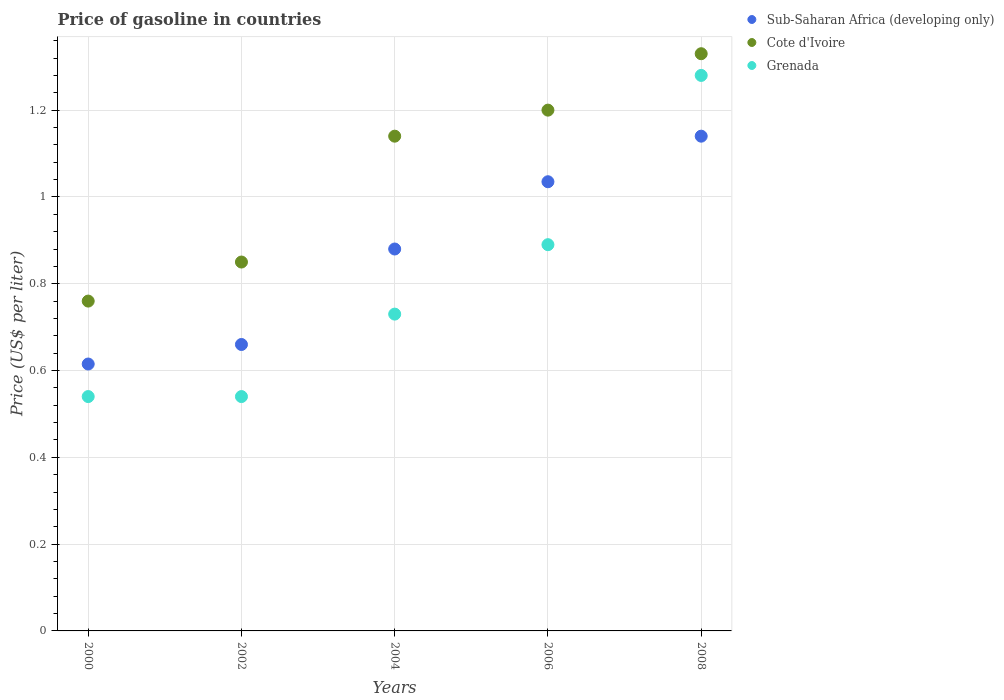Is the number of dotlines equal to the number of legend labels?
Offer a terse response. Yes. What is the price of gasoline in Grenada in 2006?
Make the answer very short. 0.89. Across all years, what is the maximum price of gasoline in Sub-Saharan Africa (developing only)?
Ensure brevity in your answer.  1.14. Across all years, what is the minimum price of gasoline in Sub-Saharan Africa (developing only)?
Ensure brevity in your answer.  0.61. In which year was the price of gasoline in Sub-Saharan Africa (developing only) maximum?
Your response must be concise. 2008. In which year was the price of gasoline in Cote d'Ivoire minimum?
Provide a succinct answer. 2000. What is the total price of gasoline in Cote d'Ivoire in the graph?
Provide a short and direct response. 5.28. What is the difference between the price of gasoline in Grenada in 2004 and that in 2008?
Offer a terse response. -0.55. What is the difference between the price of gasoline in Grenada in 2006 and the price of gasoline in Cote d'Ivoire in 2008?
Make the answer very short. -0.44. What is the average price of gasoline in Sub-Saharan Africa (developing only) per year?
Your answer should be compact. 0.87. In the year 2006, what is the difference between the price of gasoline in Cote d'Ivoire and price of gasoline in Sub-Saharan Africa (developing only)?
Offer a very short reply. 0.17. What is the ratio of the price of gasoline in Grenada in 2004 to that in 2008?
Your response must be concise. 0.57. What is the difference between the highest and the second highest price of gasoline in Sub-Saharan Africa (developing only)?
Provide a succinct answer. 0.1. What is the difference between the highest and the lowest price of gasoline in Cote d'Ivoire?
Your answer should be compact. 0.57. Is the sum of the price of gasoline in Cote d'Ivoire in 2002 and 2006 greater than the maximum price of gasoline in Sub-Saharan Africa (developing only) across all years?
Ensure brevity in your answer.  Yes. Is it the case that in every year, the sum of the price of gasoline in Cote d'Ivoire and price of gasoline in Sub-Saharan Africa (developing only)  is greater than the price of gasoline in Grenada?
Your answer should be compact. Yes. Is the price of gasoline in Sub-Saharan Africa (developing only) strictly greater than the price of gasoline in Grenada over the years?
Offer a terse response. No. Are the values on the major ticks of Y-axis written in scientific E-notation?
Your answer should be very brief. No. Does the graph contain any zero values?
Offer a very short reply. No. Where does the legend appear in the graph?
Provide a succinct answer. Top right. How many legend labels are there?
Make the answer very short. 3. How are the legend labels stacked?
Ensure brevity in your answer.  Vertical. What is the title of the graph?
Offer a terse response. Price of gasoline in countries. Does "Estonia" appear as one of the legend labels in the graph?
Offer a terse response. No. What is the label or title of the Y-axis?
Give a very brief answer. Price (US$ per liter). What is the Price (US$ per liter) of Sub-Saharan Africa (developing only) in 2000?
Offer a terse response. 0.61. What is the Price (US$ per liter) in Cote d'Ivoire in 2000?
Give a very brief answer. 0.76. What is the Price (US$ per liter) in Grenada in 2000?
Your answer should be compact. 0.54. What is the Price (US$ per liter) of Sub-Saharan Africa (developing only) in 2002?
Your response must be concise. 0.66. What is the Price (US$ per liter) of Grenada in 2002?
Your answer should be compact. 0.54. What is the Price (US$ per liter) of Sub-Saharan Africa (developing only) in 2004?
Give a very brief answer. 0.88. What is the Price (US$ per liter) in Cote d'Ivoire in 2004?
Offer a terse response. 1.14. What is the Price (US$ per liter) in Grenada in 2004?
Make the answer very short. 0.73. What is the Price (US$ per liter) in Sub-Saharan Africa (developing only) in 2006?
Offer a terse response. 1.03. What is the Price (US$ per liter) of Grenada in 2006?
Provide a succinct answer. 0.89. What is the Price (US$ per liter) in Sub-Saharan Africa (developing only) in 2008?
Ensure brevity in your answer.  1.14. What is the Price (US$ per liter) in Cote d'Ivoire in 2008?
Offer a terse response. 1.33. What is the Price (US$ per liter) in Grenada in 2008?
Ensure brevity in your answer.  1.28. Across all years, what is the maximum Price (US$ per liter) in Sub-Saharan Africa (developing only)?
Make the answer very short. 1.14. Across all years, what is the maximum Price (US$ per liter) in Cote d'Ivoire?
Your response must be concise. 1.33. Across all years, what is the maximum Price (US$ per liter) in Grenada?
Provide a succinct answer. 1.28. Across all years, what is the minimum Price (US$ per liter) of Sub-Saharan Africa (developing only)?
Provide a succinct answer. 0.61. Across all years, what is the minimum Price (US$ per liter) of Cote d'Ivoire?
Give a very brief answer. 0.76. Across all years, what is the minimum Price (US$ per liter) of Grenada?
Provide a succinct answer. 0.54. What is the total Price (US$ per liter) in Sub-Saharan Africa (developing only) in the graph?
Offer a terse response. 4.33. What is the total Price (US$ per liter) of Cote d'Ivoire in the graph?
Provide a short and direct response. 5.28. What is the total Price (US$ per liter) of Grenada in the graph?
Give a very brief answer. 3.98. What is the difference between the Price (US$ per liter) of Sub-Saharan Africa (developing only) in 2000 and that in 2002?
Provide a short and direct response. -0.04. What is the difference between the Price (US$ per liter) of Cote d'Ivoire in 2000 and that in 2002?
Ensure brevity in your answer.  -0.09. What is the difference between the Price (US$ per liter) of Grenada in 2000 and that in 2002?
Keep it short and to the point. 0. What is the difference between the Price (US$ per liter) of Sub-Saharan Africa (developing only) in 2000 and that in 2004?
Provide a succinct answer. -0.27. What is the difference between the Price (US$ per liter) of Cote d'Ivoire in 2000 and that in 2004?
Offer a very short reply. -0.38. What is the difference between the Price (US$ per liter) in Grenada in 2000 and that in 2004?
Ensure brevity in your answer.  -0.19. What is the difference between the Price (US$ per liter) in Sub-Saharan Africa (developing only) in 2000 and that in 2006?
Offer a very short reply. -0.42. What is the difference between the Price (US$ per liter) of Cote d'Ivoire in 2000 and that in 2006?
Offer a terse response. -0.44. What is the difference between the Price (US$ per liter) of Grenada in 2000 and that in 2006?
Provide a succinct answer. -0.35. What is the difference between the Price (US$ per liter) of Sub-Saharan Africa (developing only) in 2000 and that in 2008?
Make the answer very short. -0.53. What is the difference between the Price (US$ per liter) of Cote d'Ivoire in 2000 and that in 2008?
Provide a succinct answer. -0.57. What is the difference between the Price (US$ per liter) in Grenada in 2000 and that in 2008?
Your answer should be very brief. -0.74. What is the difference between the Price (US$ per liter) in Sub-Saharan Africa (developing only) in 2002 and that in 2004?
Provide a short and direct response. -0.22. What is the difference between the Price (US$ per liter) of Cote d'Ivoire in 2002 and that in 2004?
Provide a succinct answer. -0.29. What is the difference between the Price (US$ per liter) in Grenada in 2002 and that in 2004?
Provide a short and direct response. -0.19. What is the difference between the Price (US$ per liter) of Sub-Saharan Africa (developing only) in 2002 and that in 2006?
Ensure brevity in your answer.  -0.38. What is the difference between the Price (US$ per liter) of Cote d'Ivoire in 2002 and that in 2006?
Your answer should be compact. -0.35. What is the difference between the Price (US$ per liter) of Grenada in 2002 and that in 2006?
Provide a short and direct response. -0.35. What is the difference between the Price (US$ per liter) in Sub-Saharan Africa (developing only) in 2002 and that in 2008?
Offer a very short reply. -0.48. What is the difference between the Price (US$ per liter) of Cote d'Ivoire in 2002 and that in 2008?
Your response must be concise. -0.48. What is the difference between the Price (US$ per liter) of Grenada in 2002 and that in 2008?
Offer a terse response. -0.74. What is the difference between the Price (US$ per liter) of Sub-Saharan Africa (developing only) in 2004 and that in 2006?
Provide a short and direct response. -0.15. What is the difference between the Price (US$ per liter) of Cote d'Ivoire in 2004 and that in 2006?
Provide a succinct answer. -0.06. What is the difference between the Price (US$ per liter) of Grenada in 2004 and that in 2006?
Ensure brevity in your answer.  -0.16. What is the difference between the Price (US$ per liter) of Sub-Saharan Africa (developing only) in 2004 and that in 2008?
Your response must be concise. -0.26. What is the difference between the Price (US$ per liter) of Cote d'Ivoire in 2004 and that in 2008?
Offer a terse response. -0.19. What is the difference between the Price (US$ per liter) in Grenada in 2004 and that in 2008?
Keep it short and to the point. -0.55. What is the difference between the Price (US$ per liter) of Sub-Saharan Africa (developing only) in 2006 and that in 2008?
Ensure brevity in your answer.  -0.1. What is the difference between the Price (US$ per liter) of Cote d'Ivoire in 2006 and that in 2008?
Offer a very short reply. -0.13. What is the difference between the Price (US$ per liter) in Grenada in 2006 and that in 2008?
Provide a succinct answer. -0.39. What is the difference between the Price (US$ per liter) in Sub-Saharan Africa (developing only) in 2000 and the Price (US$ per liter) in Cote d'Ivoire in 2002?
Make the answer very short. -0.23. What is the difference between the Price (US$ per liter) in Sub-Saharan Africa (developing only) in 2000 and the Price (US$ per liter) in Grenada in 2002?
Make the answer very short. 0.07. What is the difference between the Price (US$ per liter) in Cote d'Ivoire in 2000 and the Price (US$ per liter) in Grenada in 2002?
Keep it short and to the point. 0.22. What is the difference between the Price (US$ per liter) of Sub-Saharan Africa (developing only) in 2000 and the Price (US$ per liter) of Cote d'Ivoire in 2004?
Give a very brief answer. -0.53. What is the difference between the Price (US$ per liter) in Sub-Saharan Africa (developing only) in 2000 and the Price (US$ per liter) in Grenada in 2004?
Your answer should be very brief. -0.12. What is the difference between the Price (US$ per liter) of Sub-Saharan Africa (developing only) in 2000 and the Price (US$ per liter) of Cote d'Ivoire in 2006?
Ensure brevity in your answer.  -0.58. What is the difference between the Price (US$ per liter) of Sub-Saharan Africa (developing only) in 2000 and the Price (US$ per liter) of Grenada in 2006?
Offer a very short reply. -0.28. What is the difference between the Price (US$ per liter) of Cote d'Ivoire in 2000 and the Price (US$ per liter) of Grenada in 2006?
Give a very brief answer. -0.13. What is the difference between the Price (US$ per liter) of Sub-Saharan Africa (developing only) in 2000 and the Price (US$ per liter) of Cote d'Ivoire in 2008?
Offer a very short reply. -0.71. What is the difference between the Price (US$ per liter) in Sub-Saharan Africa (developing only) in 2000 and the Price (US$ per liter) in Grenada in 2008?
Provide a succinct answer. -0.67. What is the difference between the Price (US$ per liter) in Cote d'Ivoire in 2000 and the Price (US$ per liter) in Grenada in 2008?
Make the answer very short. -0.52. What is the difference between the Price (US$ per liter) of Sub-Saharan Africa (developing only) in 2002 and the Price (US$ per liter) of Cote d'Ivoire in 2004?
Provide a succinct answer. -0.48. What is the difference between the Price (US$ per liter) of Sub-Saharan Africa (developing only) in 2002 and the Price (US$ per liter) of Grenada in 2004?
Keep it short and to the point. -0.07. What is the difference between the Price (US$ per liter) in Cote d'Ivoire in 2002 and the Price (US$ per liter) in Grenada in 2004?
Your response must be concise. 0.12. What is the difference between the Price (US$ per liter) of Sub-Saharan Africa (developing only) in 2002 and the Price (US$ per liter) of Cote d'Ivoire in 2006?
Your response must be concise. -0.54. What is the difference between the Price (US$ per liter) in Sub-Saharan Africa (developing only) in 2002 and the Price (US$ per liter) in Grenada in 2006?
Give a very brief answer. -0.23. What is the difference between the Price (US$ per liter) of Cote d'Ivoire in 2002 and the Price (US$ per liter) of Grenada in 2006?
Your response must be concise. -0.04. What is the difference between the Price (US$ per liter) in Sub-Saharan Africa (developing only) in 2002 and the Price (US$ per liter) in Cote d'Ivoire in 2008?
Your answer should be very brief. -0.67. What is the difference between the Price (US$ per liter) of Sub-Saharan Africa (developing only) in 2002 and the Price (US$ per liter) of Grenada in 2008?
Keep it short and to the point. -0.62. What is the difference between the Price (US$ per liter) of Cote d'Ivoire in 2002 and the Price (US$ per liter) of Grenada in 2008?
Your answer should be compact. -0.43. What is the difference between the Price (US$ per liter) of Sub-Saharan Africa (developing only) in 2004 and the Price (US$ per liter) of Cote d'Ivoire in 2006?
Ensure brevity in your answer.  -0.32. What is the difference between the Price (US$ per liter) of Sub-Saharan Africa (developing only) in 2004 and the Price (US$ per liter) of Grenada in 2006?
Provide a short and direct response. -0.01. What is the difference between the Price (US$ per liter) in Cote d'Ivoire in 2004 and the Price (US$ per liter) in Grenada in 2006?
Provide a succinct answer. 0.25. What is the difference between the Price (US$ per liter) in Sub-Saharan Africa (developing only) in 2004 and the Price (US$ per liter) in Cote d'Ivoire in 2008?
Provide a succinct answer. -0.45. What is the difference between the Price (US$ per liter) of Sub-Saharan Africa (developing only) in 2004 and the Price (US$ per liter) of Grenada in 2008?
Make the answer very short. -0.4. What is the difference between the Price (US$ per liter) in Cote d'Ivoire in 2004 and the Price (US$ per liter) in Grenada in 2008?
Ensure brevity in your answer.  -0.14. What is the difference between the Price (US$ per liter) in Sub-Saharan Africa (developing only) in 2006 and the Price (US$ per liter) in Cote d'Ivoire in 2008?
Your answer should be compact. -0.29. What is the difference between the Price (US$ per liter) in Sub-Saharan Africa (developing only) in 2006 and the Price (US$ per liter) in Grenada in 2008?
Offer a very short reply. -0.24. What is the difference between the Price (US$ per liter) in Cote d'Ivoire in 2006 and the Price (US$ per liter) in Grenada in 2008?
Ensure brevity in your answer.  -0.08. What is the average Price (US$ per liter) of Sub-Saharan Africa (developing only) per year?
Offer a terse response. 0.87. What is the average Price (US$ per liter) of Cote d'Ivoire per year?
Your response must be concise. 1.06. What is the average Price (US$ per liter) in Grenada per year?
Your answer should be compact. 0.8. In the year 2000, what is the difference between the Price (US$ per liter) of Sub-Saharan Africa (developing only) and Price (US$ per liter) of Cote d'Ivoire?
Your response must be concise. -0.14. In the year 2000, what is the difference between the Price (US$ per liter) in Sub-Saharan Africa (developing only) and Price (US$ per liter) in Grenada?
Your answer should be very brief. 0.07. In the year 2000, what is the difference between the Price (US$ per liter) of Cote d'Ivoire and Price (US$ per liter) of Grenada?
Keep it short and to the point. 0.22. In the year 2002, what is the difference between the Price (US$ per liter) in Sub-Saharan Africa (developing only) and Price (US$ per liter) in Cote d'Ivoire?
Provide a short and direct response. -0.19. In the year 2002, what is the difference between the Price (US$ per liter) of Sub-Saharan Africa (developing only) and Price (US$ per liter) of Grenada?
Offer a very short reply. 0.12. In the year 2002, what is the difference between the Price (US$ per liter) in Cote d'Ivoire and Price (US$ per liter) in Grenada?
Give a very brief answer. 0.31. In the year 2004, what is the difference between the Price (US$ per liter) of Sub-Saharan Africa (developing only) and Price (US$ per liter) of Cote d'Ivoire?
Your response must be concise. -0.26. In the year 2004, what is the difference between the Price (US$ per liter) in Cote d'Ivoire and Price (US$ per liter) in Grenada?
Keep it short and to the point. 0.41. In the year 2006, what is the difference between the Price (US$ per liter) in Sub-Saharan Africa (developing only) and Price (US$ per liter) in Cote d'Ivoire?
Give a very brief answer. -0.17. In the year 2006, what is the difference between the Price (US$ per liter) of Sub-Saharan Africa (developing only) and Price (US$ per liter) of Grenada?
Make the answer very short. 0.14. In the year 2006, what is the difference between the Price (US$ per liter) in Cote d'Ivoire and Price (US$ per liter) in Grenada?
Offer a very short reply. 0.31. In the year 2008, what is the difference between the Price (US$ per liter) of Sub-Saharan Africa (developing only) and Price (US$ per liter) of Cote d'Ivoire?
Your response must be concise. -0.19. In the year 2008, what is the difference between the Price (US$ per liter) in Sub-Saharan Africa (developing only) and Price (US$ per liter) in Grenada?
Offer a terse response. -0.14. In the year 2008, what is the difference between the Price (US$ per liter) in Cote d'Ivoire and Price (US$ per liter) in Grenada?
Provide a succinct answer. 0.05. What is the ratio of the Price (US$ per liter) in Sub-Saharan Africa (developing only) in 2000 to that in 2002?
Your answer should be very brief. 0.93. What is the ratio of the Price (US$ per liter) in Cote d'Ivoire in 2000 to that in 2002?
Offer a terse response. 0.89. What is the ratio of the Price (US$ per liter) of Sub-Saharan Africa (developing only) in 2000 to that in 2004?
Keep it short and to the point. 0.7. What is the ratio of the Price (US$ per liter) of Cote d'Ivoire in 2000 to that in 2004?
Ensure brevity in your answer.  0.67. What is the ratio of the Price (US$ per liter) in Grenada in 2000 to that in 2004?
Provide a succinct answer. 0.74. What is the ratio of the Price (US$ per liter) in Sub-Saharan Africa (developing only) in 2000 to that in 2006?
Your answer should be very brief. 0.59. What is the ratio of the Price (US$ per liter) of Cote d'Ivoire in 2000 to that in 2006?
Provide a short and direct response. 0.63. What is the ratio of the Price (US$ per liter) in Grenada in 2000 to that in 2006?
Keep it short and to the point. 0.61. What is the ratio of the Price (US$ per liter) of Sub-Saharan Africa (developing only) in 2000 to that in 2008?
Make the answer very short. 0.54. What is the ratio of the Price (US$ per liter) in Cote d'Ivoire in 2000 to that in 2008?
Offer a very short reply. 0.57. What is the ratio of the Price (US$ per liter) of Grenada in 2000 to that in 2008?
Keep it short and to the point. 0.42. What is the ratio of the Price (US$ per liter) of Sub-Saharan Africa (developing only) in 2002 to that in 2004?
Provide a short and direct response. 0.75. What is the ratio of the Price (US$ per liter) in Cote d'Ivoire in 2002 to that in 2004?
Keep it short and to the point. 0.75. What is the ratio of the Price (US$ per liter) in Grenada in 2002 to that in 2004?
Give a very brief answer. 0.74. What is the ratio of the Price (US$ per liter) in Sub-Saharan Africa (developing only) in 2002 to that in 2006?
Your answer should be compact. 0.64. What is the ratio of the Price (US$ per liter) of Cote d'Ivoire in 2002 to that in 2006?
Offer a very short reply. 0.71. What is the ratio of the Price (US$ per liter) of Grenada in 2002 to that in 2006?
Give a very brief answer. 0.61. What is the ratio of the Price (US$ per liter) of Sub-Saharan Africa (developing only) in 2002 to that in 2008?
Make the answer very short. 0.58. What is the ratio of the Price (US$ per liter) in Cote d'Ivoire in 2002 to that in 2008?
Offer a terse response. 0.64. What is the ratio of the Price (US$ per liter) of Grenada in 2002 to that in 2008?
Make the answer very short. 0.42. What is the ratio of the Price (US$ per liter) in Sub-Saharan Africa (developing only) in 2004 to that in 2006?
Your response must be concise. 0.85. What is the ratio of the Price (US$ per liter) of Cote d'Ivoire in 2004 to that in 2006?
Offer a very short reply. 0.95. What is the ratio of the Price (US$ per liter) of Grenada in 2004 to that in 2006?
Provide a short and direct response. 0.82. What is the ratio of the Price (US$ per liter) of Sub-Saharan Africa (developing only) in 2004 to that in 2008?
Provide a short and direct response. 0.77. What is the ratio of the Price (US$ per liter) in Cote d'Ivoire in 2004 to that in 2008?
Your answer should be very brief. 0.86. What is the ratio of the Price (US$ per liter) of Grenada in 2004 to that in 2008?
Ensure brevity in your answer.  0.57. What is the ratio of the Price (US$ per liter) of Sub-Saharan Africa (developing only) in 2006 to that in 2008?
Provide a short and direct response. 0.91. What is the ratio of the Price (US$ per liter) of Cote d'Ivoire in 2006 to that in 2008?
Ensure brevity in your answer.  0.9. What is the ratio of the Price (US$ per liter) of Grenada in 2006 to that in 2008?
Make the answer very short. 0.7. What is the difference between the highest and the second highest Price (US$ per liter) of Sub-Saharan Africa (developing only)?
Give a very brief answer. 0.1. What is the difference between the highest and the second highest Price (US$ per liter) in Cote d'Ivoire?
Provide a succinct answer. 0.13. What is the difference between the highest and the second highest Price (US$ per liter) in Grenada?
Provide a short and direct response. 0.39. What is the difference between the highest and the lowest Price (US$ per liter) of Sub-Saharan Africa (developing only)?
Offer a very short reply. 0.53. What is the difference between the highest and the lowest Price (US$ per liter) in Cote d'Ivoire?
Offer a very short reply. 0.57. What is the difference between the highest and the lowest Price (US$ per liter) in Grenada?
Ensure brevity in your answer.  0.74. 